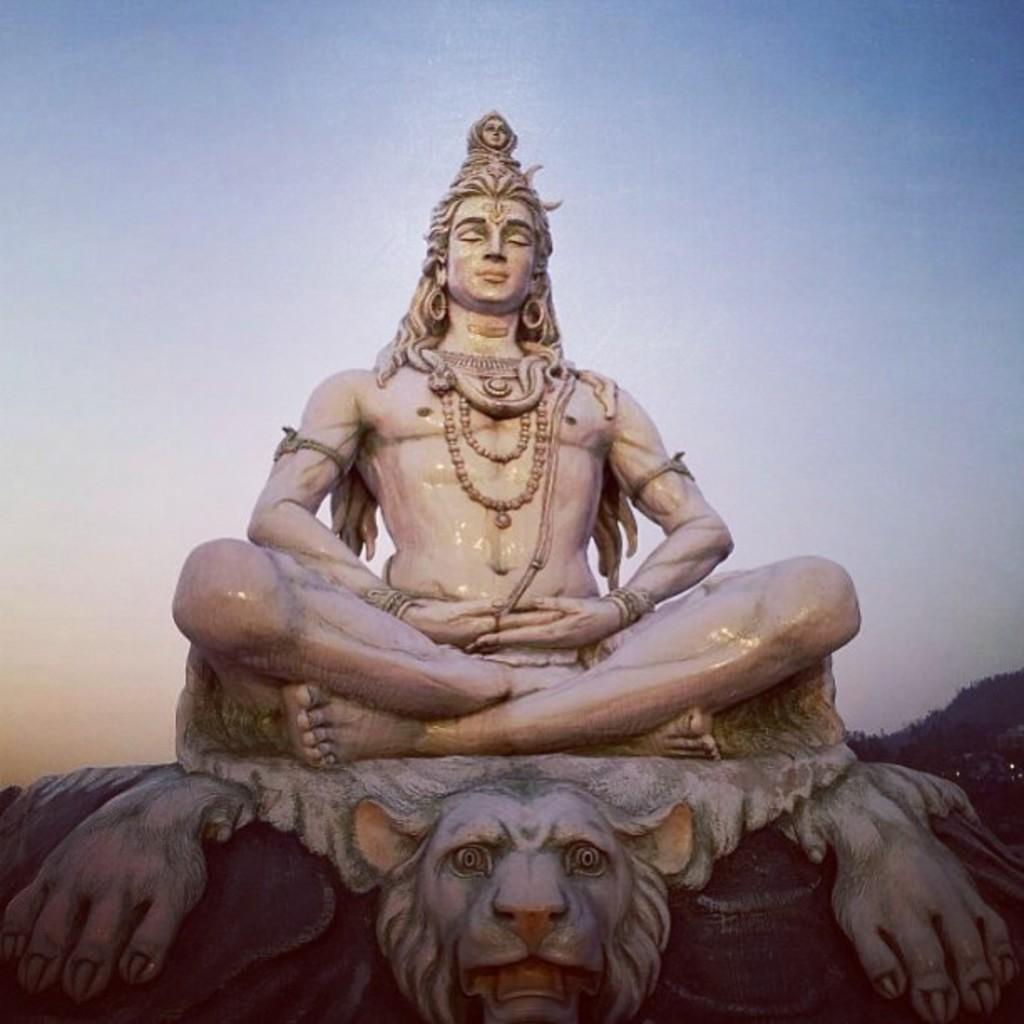What is the main subject of the image? There is a sculpture of Lord Shiva in the image. What is the sculpture sitting on? The sculpture is sitting on a lion base. How does the sculpture appear in the image? The sculpture appears to be shining. What can be seen in the background of the image? There is a sky visible in the background of the image. How many prints of the sculpture can be seen in the image? There is only one sculpture of Lord Shiva visible in the image, so there are no prints present. What type of mitten is being used to clean the sculpture in the image? There is no mitten or cleaning activity depicted in the image; it only shows the sculpture of Lord Shiva sitting on a lion base. 